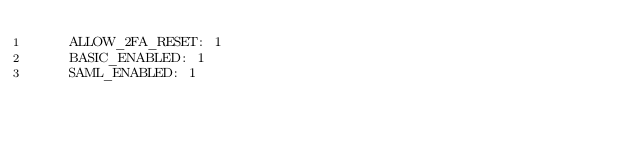<code> <loc_0><loc_0><loc_500><loc_500><_YAML_>    ALLOW_2FA_RESET: 1
    BASIC_ENABLED: 1
    SAML_ENABLED: 1
</code> 